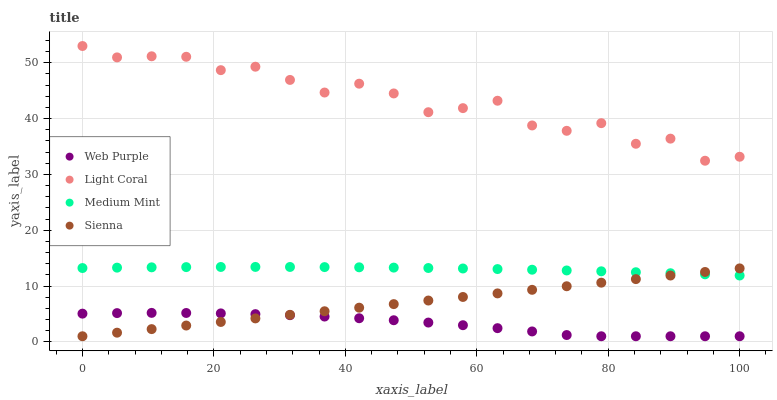Does Web Purple have the minimum area under the curve?
Answer yes or no. Yes. Does Light Coral have the maximum area under the curve?
Answer yes or no. Yes. Does Medium Mint have the minimum area under the curve?
Answer yes or no. No. Does Medium Mint have the maximum area under the curve?
Answer yes or no. No. Is Sienna the smoothest?
Answer yes or no. Yes. Is Light Coral the roughest?
Answer yes or no. Yes. Is Medium Mint the smoothest?
Answer yes or no. No. Is Medium Mint the roughest?
Answer yes or no. No. Does Web Purple have the lowest value?
Answer yes or no. Yes. Does Medium Mint have the lowest value?
Answer yes or no. No. Does Light Coral have the highest value?
Answer yes or no. Yes. Does Medium Mint have the highest value?
Answer yes or no. No. Is Sienna less than Light Coral?
Answer yes or no. Yes. Is Light Coral greater than Web Purple?
Answer yes or no. Yes. Does Sienna intersect Web Purple?
Answer yes or no. Yes. Is Sienna less than Web Purple?
Answer yes or no. No. Is Sienna greater than Web Purple?
Answer yes or no. No. Does Sienna intersect Light Coral?
Answer yes or no. No. 